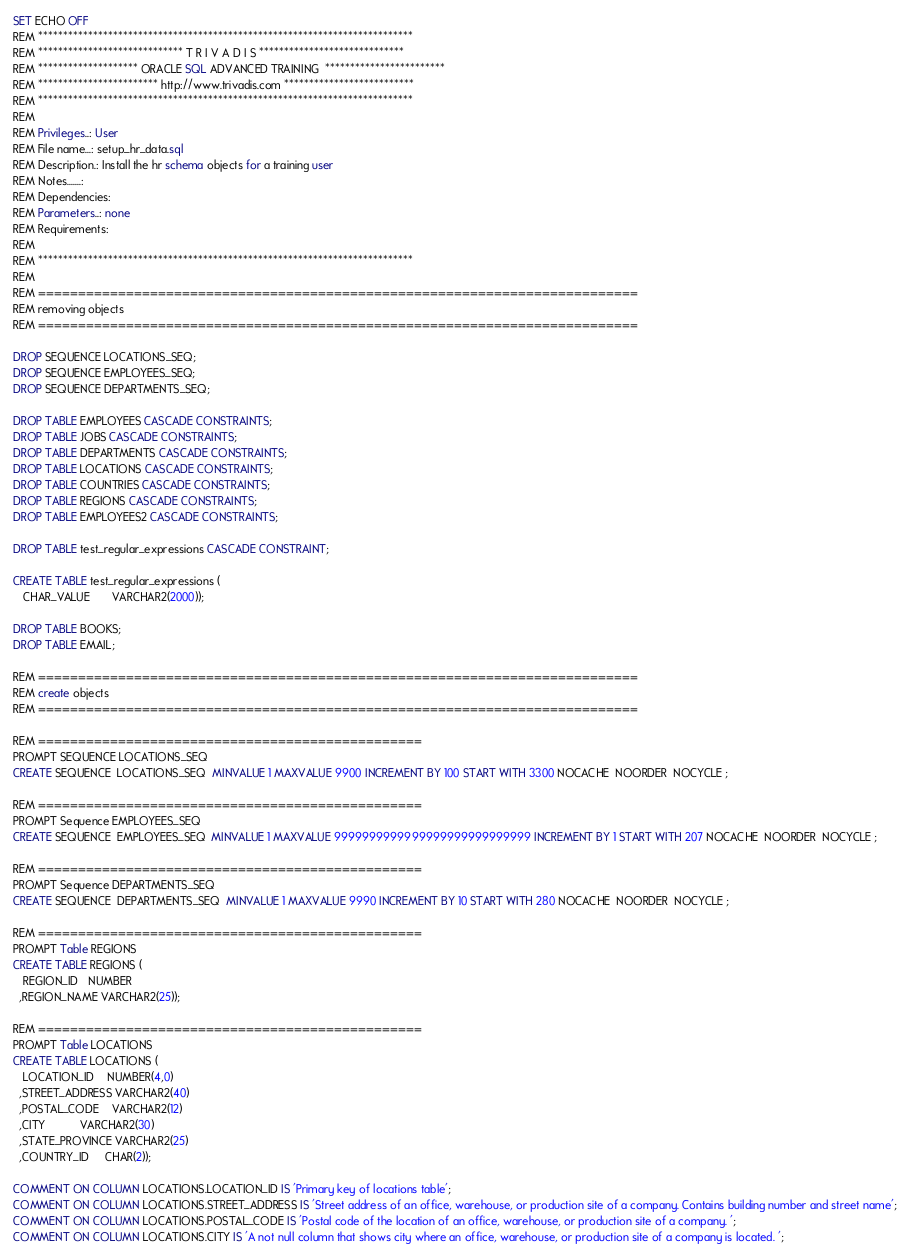Convert code to text. <code><loc_0><loc_0><loc_500><loc_500><_SQL_>SET ECHO OFF
REM ***************************************************************************
REM ***************************** T R I V A D I S *****************************
REM ******************** ORACLE SQL ADVANCED TRAINING  ************************
REM ************************ http://www.trivadis.com **************************
REM ***************************************************************************
REM
REM Privileges..: User
REM File name...: setup_hr_data.sql
REM Description.: Install the hr schema objects for a training user
REM Notes.......: 
REM Dependencies: 
REM Parameters..: none
REM Requirements: 
REM
REM ***************************************************************************
REM 
REM ===========================================================================
REM removing objects
REM ===========================================================================

DROP SEQUENCE LOCATIONS_SEQ;
DROP SEQUENCE EMPLOYEES_SEQ;
DROP SEQUENCE DEPARTMENTS_SEQ;

DROP TABLE EMPLOYEES CASCADE CONSTRAINTS;
DROP TABLE JOBS CASCADE CONSTRAINTS;
DROP TABLE DEPARTMENTS CASCADE CONSTRAINTS;
DROP TABLE LOCATIONS CASCADE CONSTRAINTS;
DROP TABLE COUNTRIES CASCADE CONSTRAINTS;
DROP TABLE REGIONS CASCADE CONSTRAINTS;
DROP TABLE EMPLOYEES2 CASCADE CONSTRAINTS;

DROP TABLE test_regular_expressions CASCADE CONSTRAINT;

CREATE TABLE test_regular_expressions (
   CHAR_VALUE       VARCHAR2(2000));

DROP TABLE BOOKS;
DROP TABLE EMAIL;

REM ===========================================================================
REM create objects
REM ===========================================================================

REM ================================================
PROMPT SEQUENCE LOCATIONS_SEQ
CREATE SEQUENCE  LOCATIONS_SEQ  MINVALUE 1 MAXVALUE 9900 INCREMENT BY 100 START WITH 3300 NOCACHE  NOORDER  NOCYCLE ;

REM ================================================
PROMPT Sequence EMPLOYEES_SEQ
CREATE SEQUENCE  EMPLOYEES_SEQ  MINVALUE 1 MAXVALUE 9999999999999999999999999999 INCREMENT BY 1 START WITH 207 NOCACHE  NOORDER  NOCYCLE ;

REM ================================================
PROMPT Sequence DEPARTMENTS_SEQ
CREATE SEQUENCE  DEPARTMENTS_SEQ  MINVALUE 1 MAXVALUE 9990 INCREMENT BY 10 START WITH 280 NOCACHE  NOORDER  NOCYCLE ;

REM ================================================
PROMPT Table REGIONS
CREATE TABLE REGIONS (	
   REGION_ID   NUMBER
  ,REGION_NAME VARCHAR2(25));

REM ================================================
PROMPT Table LOCATIONS
CREATE TABLE LOCATIONS (	
   LOCATION_ID    NUMBER(4,0)
  ,STREET_ADDRESS VARCHAR2(40)
  ,POSTAL_CODE    VARCHAR2(12)
  ,CITY           VARCHAR2(30)
  ,STATE_PROVINCE VARCHAR2(25)
  ,COUNTRY_ID     CHAR(2));

COMMENT ON COLUMN LOCATIONS.LOCATION_ID IS 'Primary key of locations table';
COMMENT ON COLUMN LOCATIONS.STREET_ADDRESS IS 'Street address of an office, warehouse, or production site of a company. Contains building number and street name';
COMMENT ON COLUMN LOCATIONS.POSTAL_CODE IS 'Postal code of the location of an office, warehouse, or production site of a company. ';
COMMENT ON COLUMN LOCATIONS.CITY IS 'A not null column that shows city where an office, warehouse, or production site of a company is located. ';</code> 